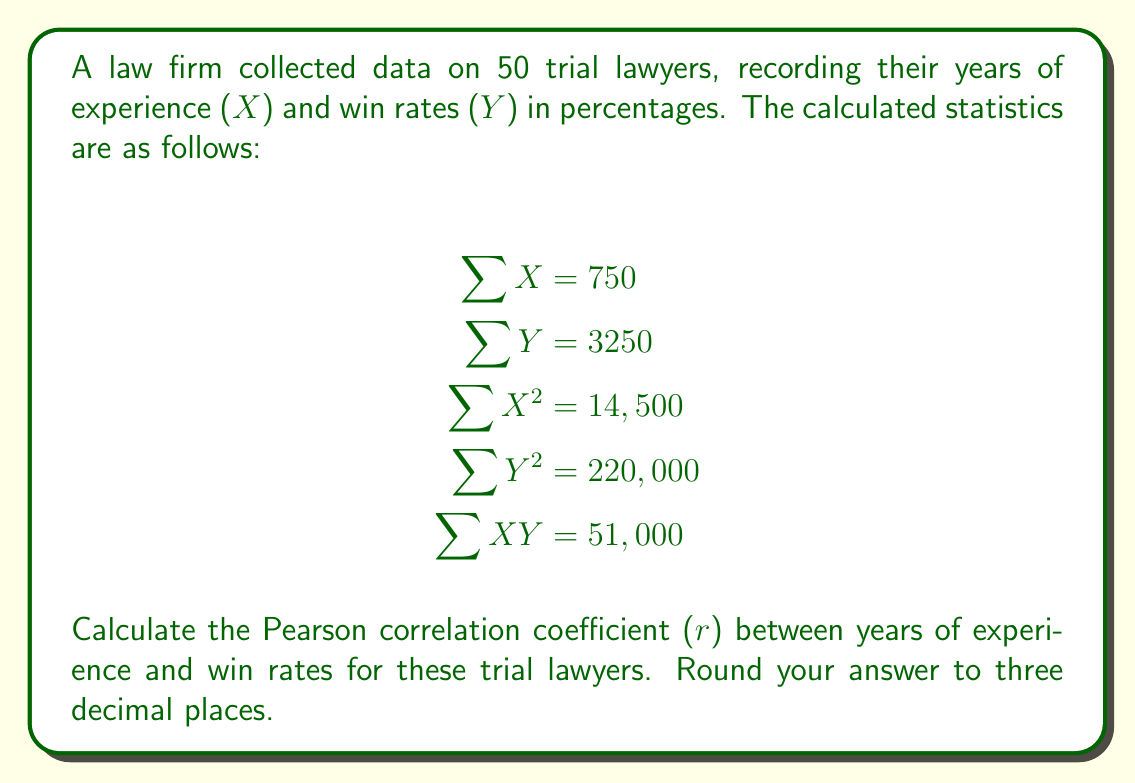Show me your answer to this math problem. To calculate the Pearson correlation coefficient (r), we'll use the formula:

$$r = \frac{n\sum{XY} - \sum{X}\sum{Y}}{\sqrt{[n\sum{X^2} - (\sum{X})^2][n\sum{Y^2} - (\sum{Y})^2]}}$$

Where n is the number of lawyers (50 in this case).

Step 1: Calculate $n\sum{XY}$
$50 \times 51,000 = 2,550,000$

Step 2: Calculate $\sum{X}\sum{Y}$
$750 \times 3250 = 2,437,500$

Step 3: Calculate the numerator
$2,550,000 - 2,437,500 = 112,500$

Step 4: Calculate $n\sum{X^2}$
$50 \times 14,500 = 725,000$

Step 5: Calculate $(\sum{X})^2$
$750^2 = 562,500$

Step 6: Calculate $n\sum{Y^2}$
$50 \times 220,000 = 11,000,000$

Step 7: Calculate $(\sum{Y})^2$
$3250^2 = 10,562,500$

Step 8: Calculate the denominator
$\sqrt{[725,000 - 562,500][11,000,000 - 10,562,500]}$
$= \sqrt{162,500 \times 437,500}$
$= \sqrt{71,093,750,000}$
$= 266,635.52$

Step 9: Calculate r
$r = \frac{112,500}{266,635.52} = 0.422$

Step 10: Round to three decimal places
$r = 0.422$
Answer: 0.422 